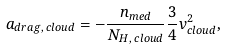Convert formula to latex. <formula><loc_0><loc_0><loc_500><loc_500>a _ { d r a g , \, c l o u d } = - \frac { n _ { m e d } } { N _ { H , \, c l o u d } } \frac { 3 } { 4 } v ^ { 2 } _ { c l o u d } ,</formula> 